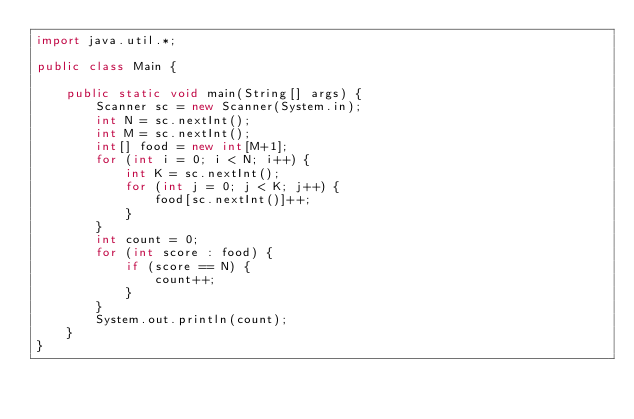Convert code to text. <code><loc_0><loc_0><loc_500><loc_500><_Java_>import java.util.*;
 
public class Main {
	
    public static void main(String[] args) {
    	Scanner sc = new Scanner(System.in);
    	int N = sc.nextInt();
    	int M = sc.nextInt();
    	int[] food = new int[M+1];
    	for (int i = 0; i < N; i++) {
    		int K = sc.nextInt();
    		for (int j = 0; j < K; j++) {
    			food[sc.nextInt()]++;
    		}
    	}
    	int count = 0;
    	for (int score : food) {
    		if (score == N) {
    			count++;
    		}
    	}
    	System.out.println(count);
    }
}</code> 